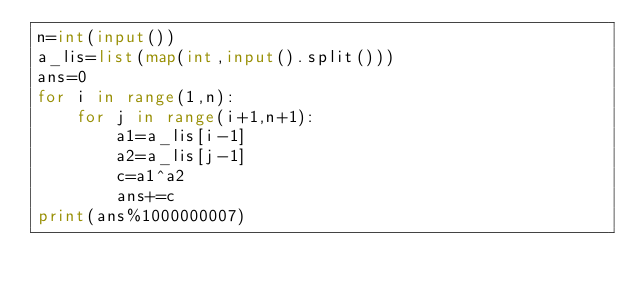<code> <loc_0><loc_0><loc_500><loc_500><_Python_>n=int(input())
a_lis=list(map(int,input().split()))
ans=0
for i in range(1,n):
    for j in range(i+1,n+1):
        a1=a_lis[i-1]
        a2=a_lis[j-1]
        c=a1^a2
        ans+=c
print(ans%1000000007)</code> 